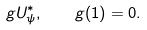<formula> <loc_0><loc_0><loc_500><loc_500>g U ^ { \ast } _ { \psi } , \quad g ( 1 ) = 0 .</formula> 